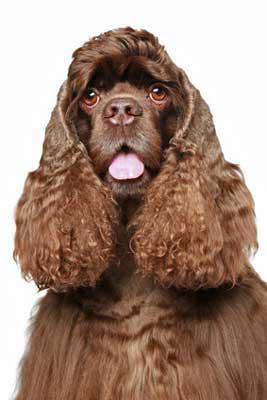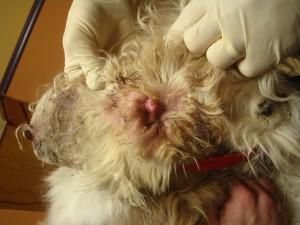The first image is the image on the left, the second image is the image on the right. For the images shown, is this caption "Human hands can be seen holding the dog's ear in one image." true? Answer yes or no. Yes. 